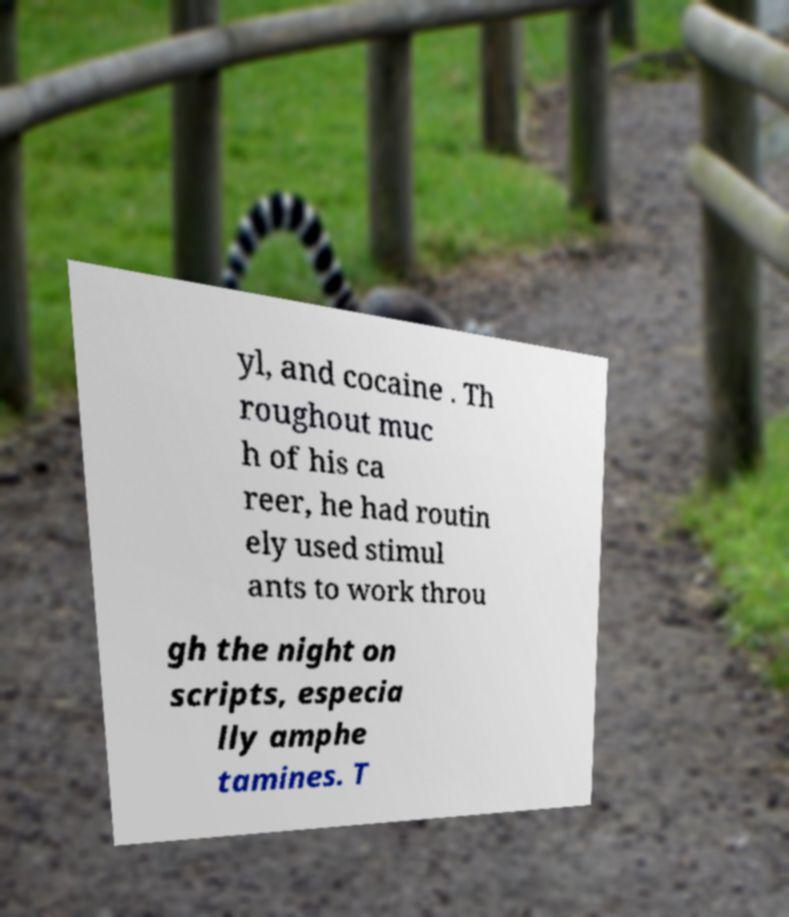I need the written content from this picture converted into text. Can you do that? yl, and cocaine . Th roughout muc h of his ca reer, he had routin ely used stimul ants to work throu gh the night on scripts, especia lly amphe tamines. T 